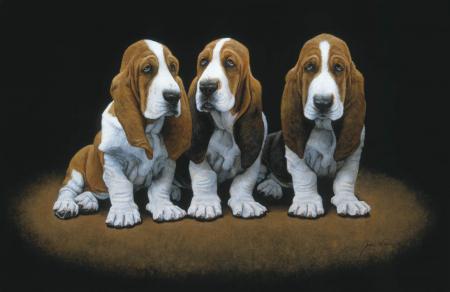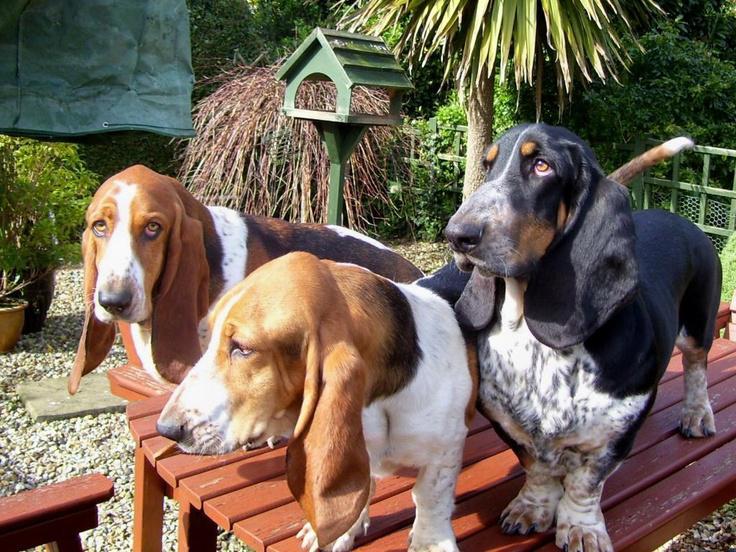The first image is the image on the left, the second image is the image on the right. Assess this claim about the two images: "In each image there are exactly three dogs right next to each other.". Correct or not? Answer yes or no. Yes. The first image is the image on the left, the second image is the image on the right. Assess this claim about the two images: "There are three dogs in the grass in the right image.". Correct or not? Answer yes or no. No. 